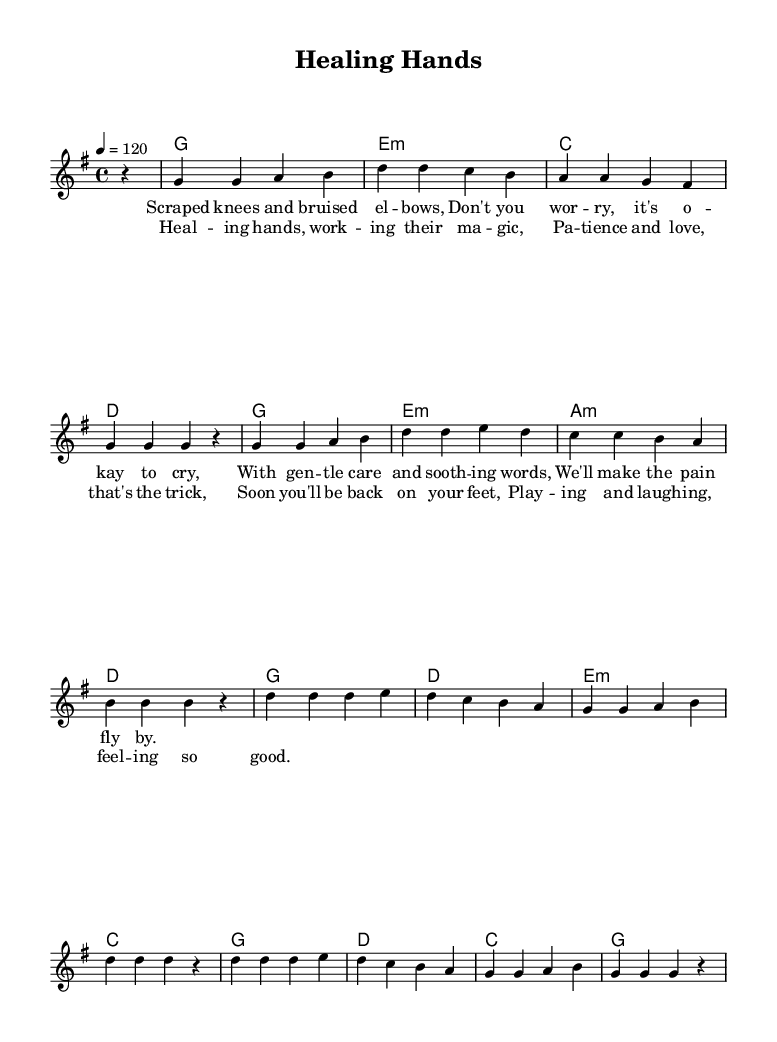What is the key signature of this music? The key signature is indicated by the sharp signs (if any) at the beginning of the staff. In this case, there are no sharps or flats shown, which signifies the key of G major.
Answer: G major What is the time signature of this music? The time signature is notated at the beginning of the music with the numbers above the vertical line. Here, the time signature shows a four on top and a four on the bottom, indicating four beats per measure.
Answer: 4/4 What is the tempo marking of this music? The tempo marking is given in beats per minute (BPM) at the beginning, expressed as a number followed by the equals sign. Here, it shows "4 = 120," indicating a moderate pace of 120 BPM.
Answer: 120 What are the first two chords of the harmonies section? The first two chords can be found in the chord-mode section beneath the melody. The first chord indicated is G (the root chord), followed by E minor.
Answer: G, E minor How many measures are in the chorus section? To find the number of measures in the chorus, we count the number of vertical lines in the lyric section that denote the end of each measure. The chorus has four separate measure lines.
Answer: 4 Which words correspond to the phrase "Healing hands"? In the lyrics, the phrase "Healing hands" occurs in the chorus section, specifically at the beginning of the first line. By looking at the alignment of the lyrics with the music notes, we see that "Healing hands" aligns clearly with a specific melodic phrase in this section.
Answer: Healing hands What two qualities are mentioned in the chorus that help in healing? The words "patience" and "love" are specifically noted in the chorus lyrics, highlighting important qualities associated with the healing process. By scanning the lyrics of the chorus, these words stand out as essential components in the context of healing.
Answer: Patience, love 